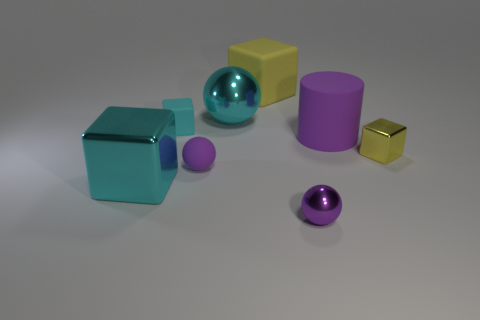Is the shape of the small yellow object the same as the small purple matte object?
Keep it short and to the point. No. What is the color of the other rubber object that is the same shape as the big yellow rubber object?
Keep it short and to the point. Cyan. What number of tiny blocks have the same color as the large matte block?
Offer a very short reply. 1. How many objects are either large rubber blocks on the left side of the tiny yellow thing or tiny blue spheres?
Give a very brief answer. 1. There is a yellow block that is to the right of the purple cylinder; how big is it?
Offer a very short reply. Small. Are there fewer blue metal blocks than large cubes?
Ensure brevity in your answer.  Yes. Is the purple ball on the left side of the big yellow block made of the same material as the big cube behind the small yellow block?
Provide a succinct answer. Yes. What is the shape of the purple thing that is in front of the large thing that is in front of the large purple matte cylinder behind the big cyan cube?
Provide a succinct answer. Sphere. What number of cyan things are made of the same material as the cyan ball?
Offer a terse response. 1. What number of rubber objects are to the right of the large cylinder that is in front of the small rubber cube?
Keep it short and to the point. 0. 